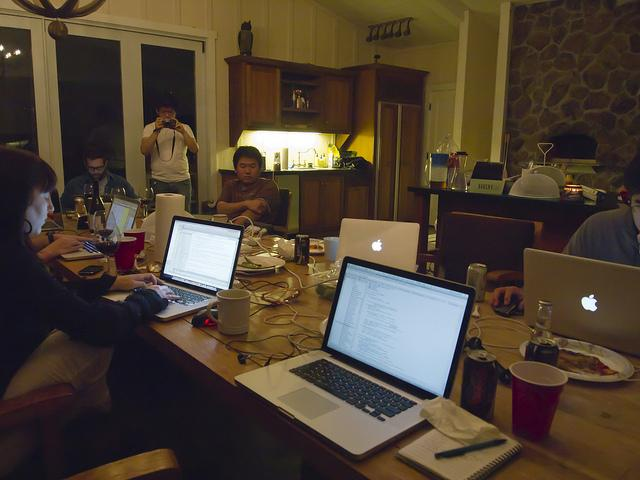What type of animal can be seen on top of the shelf near the back doors?

Choices:
A) pigeon
B) eagle
C) owl
D) hawk owl 